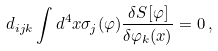<formula> <loc_0><loc_0><loc_500><loc_500>d _ { i j k } \int d ^ { 4 } x \sigma _ { j } ( \varphi ) \frac { \delta S [ \varphi ] } { \delta \varphi _ { k } ( x ) } = 0 \, ,</formula> 